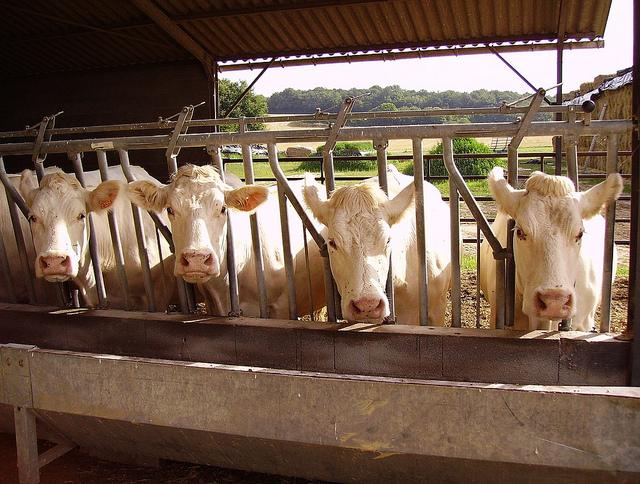Do the cows look happy?
Concise answer only. No. How many noses do you see?
Keep it brief. 4. Are they at a feeding trough?
Write a very short answer. Yes. 